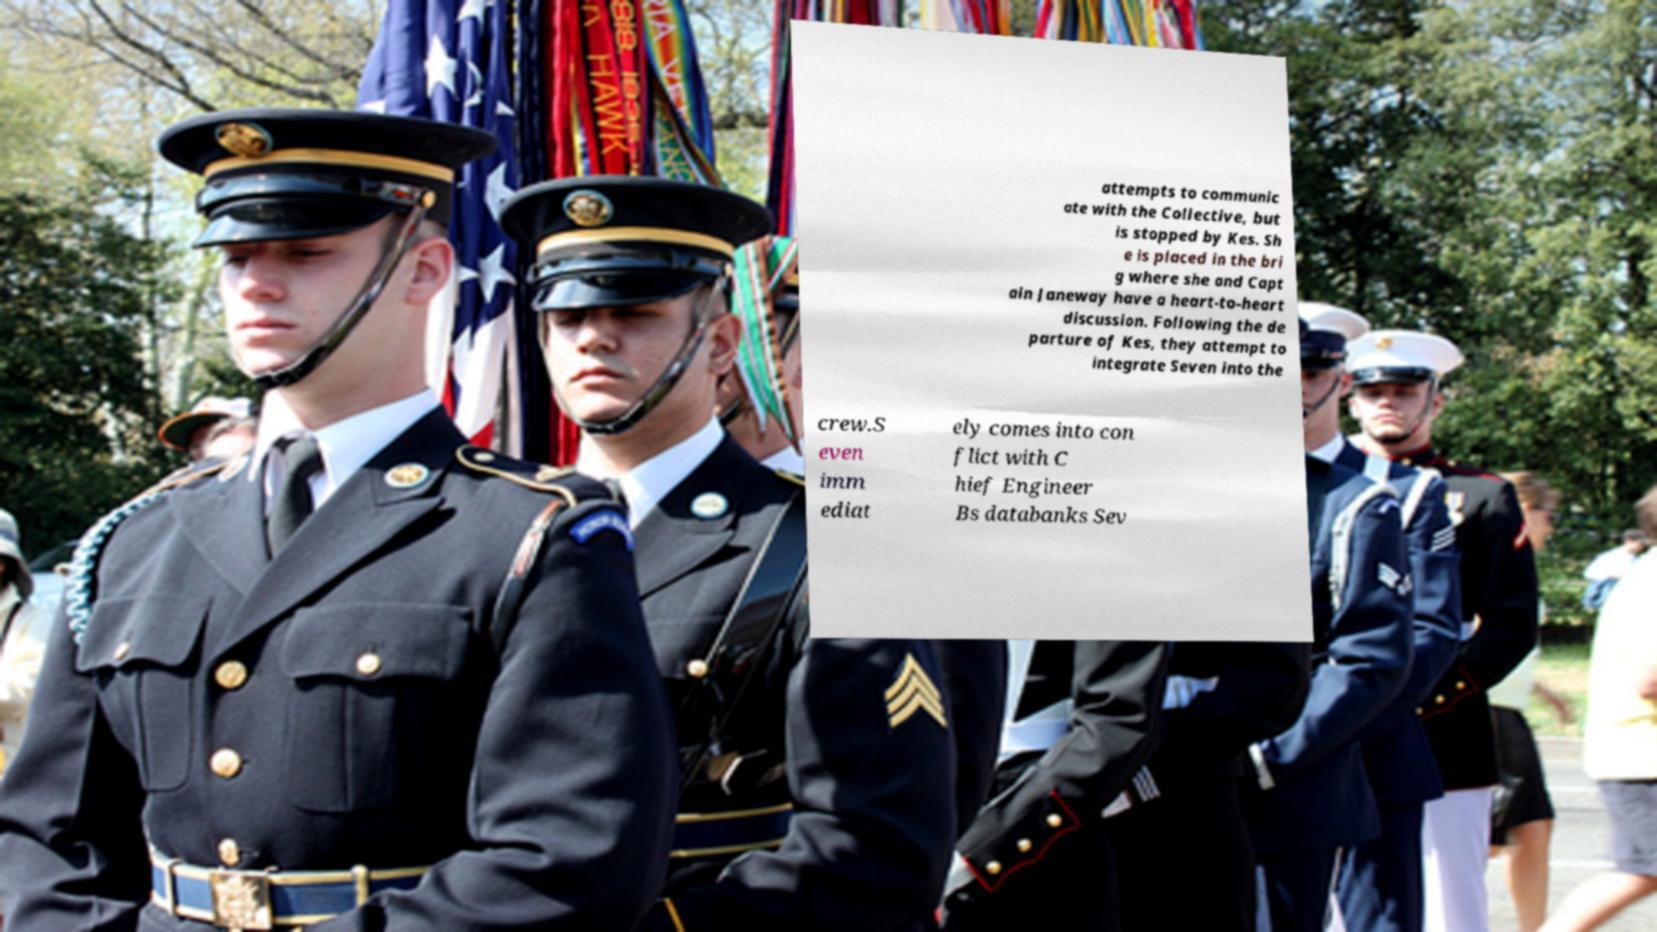Could you extract and type out the text from this image? attempts to communic ate with the Collective, but is stopped by Kes. Sh e is placed in the bri g where she and Capt ain Janeway have a heart-to-heart discussion. Following the de parture of Kes, they attempt to integrate Seven into the crew.S even imm ediat ely comes into con flict with C hief Engineer Bs databanks Sev 